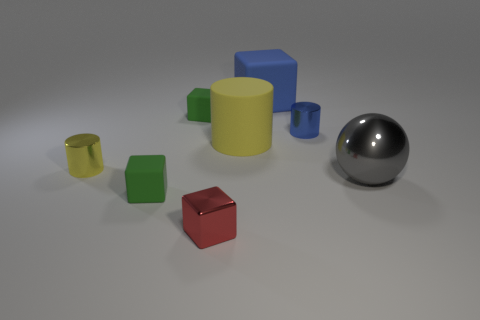Subtract all big rubber blocks. How many blocks are left? 3 Subtract all balls. How many objects are left? 7 Subtract 3 cubes. How many cubes are left? 1 Subtract all purple cubes. Subtract all gray cylinders. How many cubes are left? 4 Subtract all brown cubes. How many yellow spheres are left? 0 Subtract all big brown rubber cylinders. Subtract all large things. How many objects are left? 5 Add 1 tiny cylinders. How many tiny cylinders are left? 3 Add 1 large yellow rubber things. How many large yellow rubber things exist? 2 Add 1 shiny balls. How many objects exist? 9 Subtract all blue cylinders. How many cylinders are left? 2 